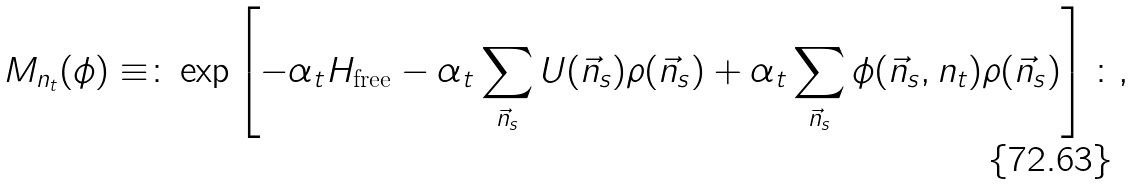Convert formula to latex. <formula><loc_0><loc_0><loc_500><loc_500>M _ { n _ { t } } ( \phi ) \equiv \colon \exp \left [ - \alpha _ { t } H _ { \text {free} } - \alpha _ { t } \sum _ { \vec { n } _ { s } } U ( \vec { n } _ { s } ) \rho ( \vec { n } _ { s } ) + \alpha _ { t } \sum _ { \vec { n } _ { s } } \phi ( \vec { n } _ { s } , n _ { t } ) \rho ( \vec { n } _ { s } ) \right ] \colon ,</formula> 